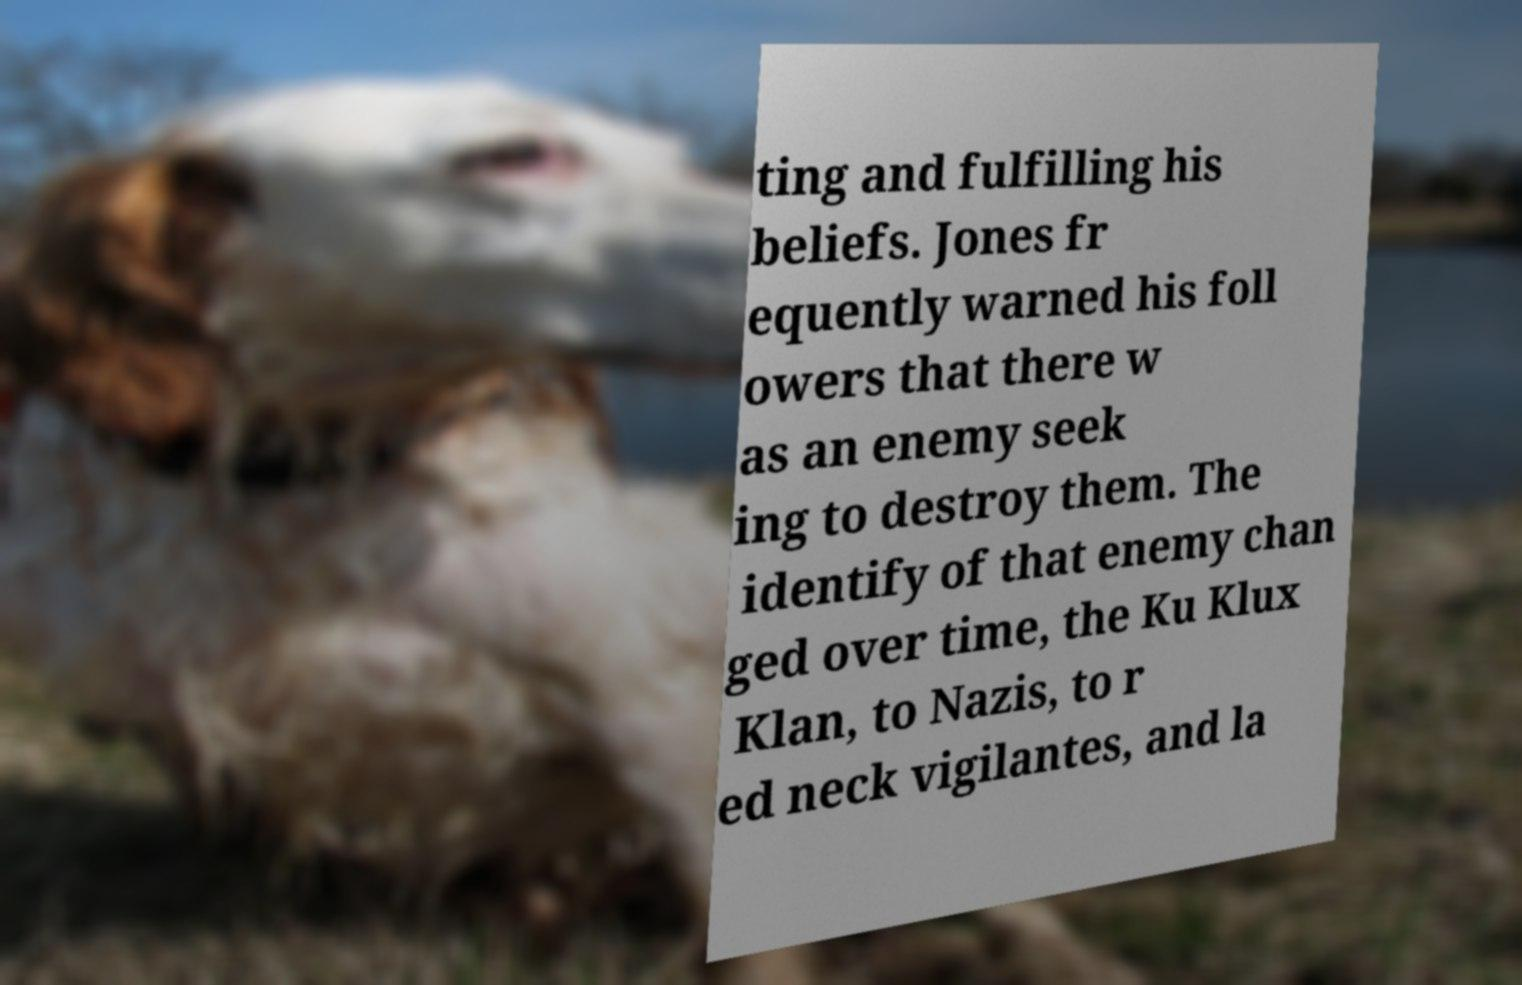I need the written content from this picture converted into text. Can you do that? ting and fulfilling his beliefs. Jones fr equently warned his foll owers that there w as an enemy seek ing to destroy them. The identify of that enemy chan ged over time, the Ku Klux Klan, to Nazis, to r ed neck vigilantes, and la 